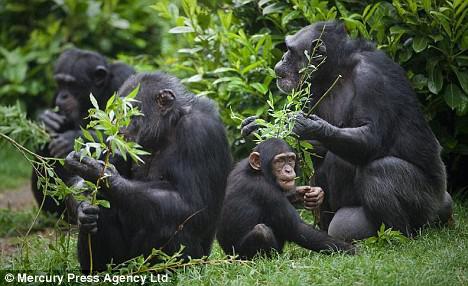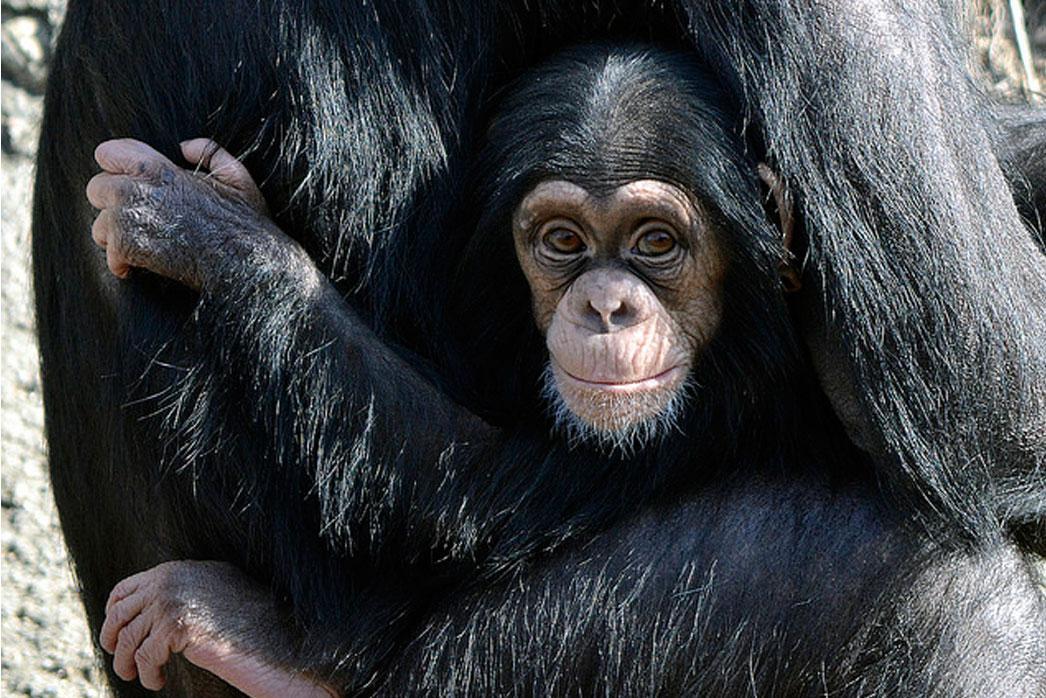The first image is the image on the left, the second image is the image on the right. Given the left and right images, does the statement "The image on the right contains a baby and its mother." hold true? Answer yes or no. Yes. The first image is the image on the left, the second image is the image on the right. Considering the images on both sides, is "The right image shows a chimp with an animal on its back." valid? Answer yes or no. No. 